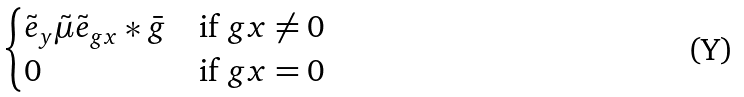Convert formula to latex. <formula><loc_0><loc_0><loc_500><loc_500>\begin{cases} \tilde { e } _ { y } \tilde { \mu } \tilde { e } _ { g x } * \bar { g } & \text {if $gx\ne 0$} \\ 0 & \text {if $gx=0$} \end{cases}</formula> 